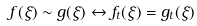<formula> <loc_0><loc_0><loc_500><loc_500>f ( \xi ) \sim g ( \xi ) \leftrightarrow f _ { t } ( \xi ) = g _ { t } ( \xi )</formula> 